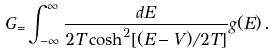Convert formula to latex. <formula><loc_0><loc_0><loc_500><loc_500>G _ { = } \int _ { - \infty } ^ { \infty } \frac { d E } { 2 T \cosh ^ { 2 } [ ( E - V ) / 2 T ] } g ( E ) \, .</formula> 